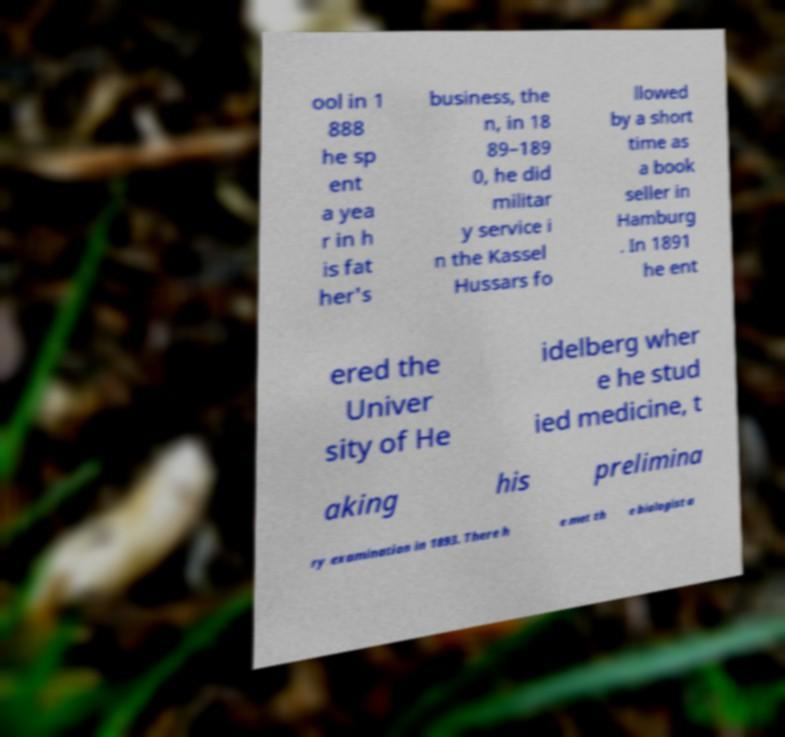For documentation purposes, I need the text within this image transcribed. Could you provide that? ool in 1 888 he sp ent a yea r in h is fat her's business, the n, in 18 89–189 0, he did militar y service i n the Kassel Hussars fo llowed by a short time as a book seller in Hamburg . In 1891 he ent ered the Univer sity of He idelberg wher e he stud ied medicine, t aking his prelimina ry examination in 1893. There h e met th e biologist a 